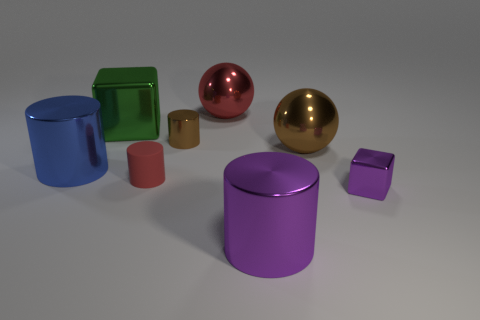Subtract all purple metal cylinders. How many cylinders are left? 3 Add 1 big yellow metal cylinders. How many objects exist? 9 Subtract all blue cylinders. How many cylinders are left? 3 Subtract all balls. How many objects are left? 6 Subtract all green cylinders. Subtract all red balls. How many cylinders are left? 4 Add 7 big cyan matte spheres. How many big cyan matte spheres exist? 7 Subtract 0 cyan cylinders. How many objects are left? 8 Subtract all tiny blue matte things. Subtract all large blue cylinders. How many objects are left? 7 Add 6 large brown balls. How many large brown balls are left? 7 